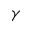Convert formula to latex. <formula><loc_0><loc_0><loc_500><loc_500>\gamma</formula> 